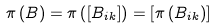<formula> <loc_0><loc_0><loc_500><loc_500>\pi \left ( B \right ) = \pi \left ( \left [ B _ { i k } \right ] \right ) = \left [ \pi \left ( B _ { i k } \right ) \right ]</formula> 